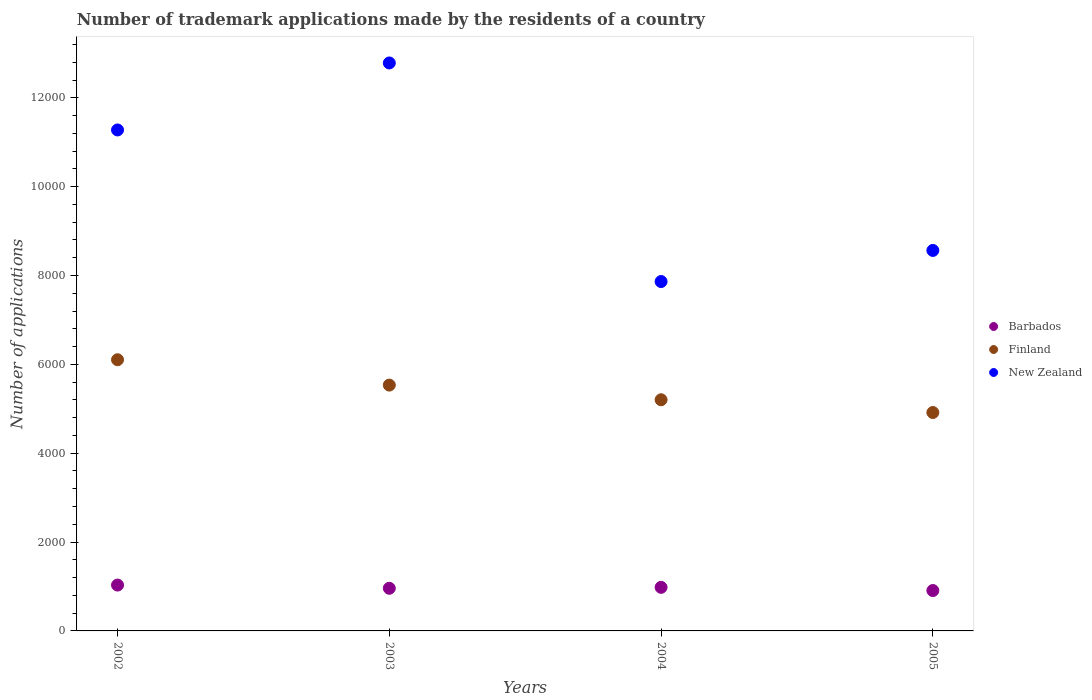How many different coloured dotlines are there?
Provide a succinct answer. 3. Is the number of dotlines equal to the number of legend labels?
Provide a short and direct response. Yes. What is the number of trademark applications made by the residents in Finland in 2002?
Provide a succinct answer. 6104. Across all years, what is the maximum number of trademark applications made by the residents in Finland?
Your response must be concise. 6104. Across all years, what is the minimum number of trademark applications made by the residents in New Zealand?
Your answer should be compact. 7864. In which year was the number of trademark applications made by the residents in New Zealand minimum?
Provide a succinct answer. 2004. What is the total number of trademark applications made by the residents in Finland in the graph?
Offer a very short reply. 2.18e+04. What is the difference between the number of trademark applications made by the residents in New Zealand in 2004 and that in 2005?
Make the answer very short. -700. What is the difference between the number of trademark applications made by the residents in New Zealand in 2004 and the number of trademark applications made by the residents in Finland in 2005?
Provide a succinct answer. 2948. What is the average number of trademark applications made by the residents in New Zealand per year?
Provide a short and direct response. 1.01e+04. In the year 2005, what is the difference between the number of trademark applications made by the residents in Finland and number of trademark applications made by the residents in Barbados?
Your response must be concise. 4007. In how many years, is the number of trademark applications made by the residents in New Zealand greater than 2000?
Your answer should be compact. 4. What is the ratio of the number of trademark applications made by the residents in Barbados in 2002 to that in 2003?
Your answer should be compact. 1.07. What is the difference between the highest and the second highest number of trademark applications made by the residents in Barbados?
Give a very brief answer. 51. What is the difference between the highest and the lowest number of trademark applications made by the residents in New Zealand?
Offer a terse response. 4920. Does the number of trademark applications made by the residents in Barbados monotonically increase over the years?
Keep it short and to the point. No. Is the number of trademark applications made by the residents in Finland strictly less than the number of trademark applications made by the residents in New Zealand over the years?
Provide a short and direct response. Yes. How many dotlines are there?
Provide a short and direct response. 3. What is the difference between two consecutive major ticks on the Y-axis?
Give a very brief answer. 2000. Does the graph contain any zero values?
Offer a terse response. No. Where does the legend appear in the graph?
Make the answer very short. Center right. How many legend labels are there?
Your response must be concise. 3. What is the title of the graph?
Provide a succinct answer. Number of trademark applications made by the residents of a country. What is the label or title of the Y-axis?
Give a very brief answer. Number of applications. What is the Number of applications of Barbados in 2002?
Your answer should be compact. 1032. What is the Number of applications in Finland in 2002?
Offer a terse response. 6104. What is the Number of applications of New Zealand in 2002?
Give a very brief answer. 1.13e+04. What is the Number of applications of Barbados in 2003?
Your answer should be compact. 960. What is the Number of applications in Finland in 2003?
Offer a very short reply. 5533. What is the Number of applications of New Zealand in 2003?
Offer a terse response. 1.28e+04. What is the Number of applications of Barbados in 2004?
Offer a very short reply. 981. What is the Number of applications in Finland in 2004?
Provide a succinct answer. 5203. What is the Number of applications in New Zealand in 2004?
Give a very brief answer. 7864. What is the Number of applications of Barbados in 2005?
Provide a succinct answer. 909. What is the Number of applications in Finland in 2005?
Provide a short and direct response. 4916. What is the Number of applications in New Zealand in 2005?
Give a very brief answer. 8564. Across all years, what is the maximum Number of applications in Barbados?
Provide a short and direct response. 1032. Across all years, what is the maximum Number of applications in Finland?
Provide a succinct answer. 6104. Across all years, what is the maximum Number of applications in New Zealand?
Make the answer very short. 1.28e+04. Across all years, what is the minimum Number of applications in Barbados?
Ensure brevity in your answer.  909. Across all years, what is the minimum Number of applications of Finland?
Your answer should be compact. 4916. Across all years, what is the minimum Number of applications in New Zealand?
Your answer should be compact. 7864. What is the total Number of applications in Barbados in the graph?
Your response must be concise. 3882. What is the total Number of applications in Finland in the graph?
Provide a succinct answer. 2.18e+04. What is the total Number of applications in New Zealand in the graph?
Keep it short and to the point. 4.05e+04. What is the difference between the Number of applications in Finland in 2002 and that in 2003?
Your answer should be very brief. 571. What is the difference between the Number of applications of New Zealand in 2002 and that in 2003?
Your response must be concise. -1508. What is the difference between the Number of applications of Finland in 2002 and that in 2004?
Ensure brevity in your answer.  901. What is the difference between the Number of applications of New Zealand in 2002 and that in 2004?
Provide a short and direct response. 3412. What is the difference between the Number of applications of Barbados in 2002 and that in 2005?
Offer a very short reply. 123. What is the difference between the Number of applications in Finland in 2002 and that in 2005?
Provide a succinct answer. 1188. What is the difference between the Number of applications in New Zealand in 2002 and that in 2005?
Offer a terse response. 2712. What is the difference between the Number of applications of Finland in 2003 and that in 2004?
Provide a short and direct response. 330. What is the difference between the Number of applications of New Zealand in 2003 and that in 2004?
Keep it short and to the point. 4920. What is the difference between the Number of applications in Finland in 2003 and that in 2005?
Your answer should be very brief. 617. What is the difference between the Number of applications in New Zealand in 2003 and that in 2005?
Offer a very short reply. 4220. What is the difference between the Number of applications in Barbados in 2004 and that in 2005?
Make the answer very short. 72. What is the difference between the Number of applications of Finland in 2004 and that in 2005?
Ensure brevity in your answer.  287. What is the difference between the Number of applications of New Zealand in 2004 and that in 2005?
Your answer should be compact. -700. What is the difference between the Number of applications in Barbados in 2002 and the Number of applications in Finland in 2003?
Offer a terse response. -4501. What is the difference between the Number of applications of Barbados in 2002 and the Number of applications of New Zealand in 2003?
Make the answer very short. -1.18e+04. What is the difference between the Number of applications of Finland in 2002 and the Number of applications of New Zealand in 2003?
Provide a succinct answer. -6680. What is the difference between the Number of applications of Barbados in 2002 and the Number of applications of Finland in 2004?
Your answer should be compact. -4171. What is the difference between the Number of applications of Barbados in 2002 and the Number of applications of New Zealand in 2004?
Give a very brief answer. -6832. What is the difference between the Number of applications of Finland in 2002 and the Number of applications of New Zealand in 2004?
Your response must be concise. -1760. What is the difference between the Number of applications of Barbados in 2002 and the Number of applications of Finland in 2005?
Your answer should be very brief. -3884. What is the difference between the Number of applications of Barbados in 2002 and the Number of applications of New Zealand in 2005?
Keep it short and to the point. -7532. What is the difference between the Number of applications in Finland in 2002 and the Number of applications in New Zealand in 2005?
Your answer should be compact. -2460. What is the difference between the Number of applications of Barbados in 2003 and the Number of applications of Finland in 2004?
Make the answer very short. -4243. What is the difference between the Number of applications of Barbados in 2003 and the Number of applications of New Zealand in 2004?
Your response must be concise. -6904. What is the difference between the Number of applications in Finland in 2003 and the Number of applications in New Zealand in 2004?
Your answer should be compact. -2331. What is the difference between the Number of applications in Barbados in 2003 and the Number of applications in Finland in 2005?
Your response must be concise. -3956. What is the difference between the Number of applications of Barbados in 2003 and the Number of applications of New Zealand in 2005?
Your answer should be very brief. -7604. What is the difference between the Number of applications in Finland in 2003 and the Number of applications in New Zealand in 2005?
Ensure brevity in your answer.  -3031. What is the difference between the Number of applications of Barbados in 2004 and the Number of applications of Finland in 2005?
Offer a very short reply. -3935. What is the difference between the Number of applications in Barbados in 2004 and the Number of applications in New Zealand in 2005?
Offer a terse response. -7583. What is the difference between the Number of applications in Finland in 2004 and the Number of applications in New Zealand in 2005?
Provide a short and direct response. -3361. What is the average Number of applications of Barbados per year?
Your response must be concise. 970.5. What is the average Number of applications in Finland per year?
Make the answer very short. 5439. What is the average Number of applications of New Zealand per year?
Provide a succinct answer. 1.01e+04. In the year 2002, what is the difference between the Number of applications of Barbados and Number of applications of Finland?
Offer a terse response. -5072. In the year 2002, what is the difference between the Number of applications of Barbados and Number of applications of New Zealand?
Keep it short and to the point. -1.02e+04. In the year 2002, what is the difference between the Number of applications of Finland and Number of applications of New Zealand?
Give a very brief answer. -5172. In the year 2003, what is the difference between the Number of applications of Barbados and Number of applications of Finland?
Make the answer very short. -4573. In the year 2003, what is the difference between the Number of applications in Barbados and Number of applications in New Zealand?
Provide a succinct answer. -1.18e+04. In the year 2003, what is the difference between the Number of applications in Finland and Number of applications in New Zealand?
Give a very brief answer. -7251. In the year 2004, what is the difference between the Number of applications in Barbados and Number of applications in Finland?
Provide a succinct answer. -4222. In the year 2004, what is the difference between the Number of applications in Barbados and Number of applications in New Zealand?
Your response must be concise. -6883. In the year 2004, what is the difference between the Number of applications of Finland and Number of applications of New Zealand?
Your response must be concise. -2661. In the year 2005, what is the difference between the Number of applications in Barbados and Number of applications in Finland?
Offer a terse response. -4007. In the year 2005, what is the difference between the Number of applications of Barbados and Number of applications of New Zealand?
Your answer should be compact. -7655. In the year 2005, what is the difference between the Number of applications in Finland and Number of applications in New Zealand?
Provide a short and direct response. -3648. What is the ratio of the Number of applications of Barbados in 2002 to that in 2003?
Offer a terse response. 1.07. What is the ratio of the Number of applications of Finland in 2002 to that in 2003?
Offer a terse response. 1.1. What is the ratio of the Number of applications of New Zealand in 2002 to that in 2003?
Give a very brief answer. 0.88. What is the ratio of the Number of applications of Barbados in 2002 to that in 2004?
Give a very brief answer. 1.05. What is the ratio of the Number of applications in Finland in 2002 to that in 2004?
Keep it short and to the point. 1.17. What is the ratio of the Number of applications in New Zealand in 2002 to that in 2004?
Ensure brevity in your answer.  1.43. What is the ratio of the Number of applications in Barbados in 2002 to that in 2005?
Offer a very short reply. 1.14. What is the ratio of the Number of applications of Finland in 2002 to that in 2005?
Offer a very short reply. 1.24. What is the ratio of the Number of applications of New Zealand in 2002 to that in 2005?
Keep it short and to the point. 1.32. What is the ratio of the Number of applications of Barbados in 2003 to that in 2004?
Offer a very short reply. 0.98. What is the ratio of the Number of applications in Finland in 2003 to that in 2004?
Your answer should be compact. 1.06. What is the ratio of the Number of applications of New Zealand in 2003 to that in 2004?
Make the answer very short. 1.63. What is the ratio of the Number of applications of Barbados in 2003 to that in 2005?
Give a very brief answer. 1.06. What is the ratio of the Number of applications of Finland in 2003 to that in 2005?
Your response must be concise. 1.13. What is the ratio of the Number of applications of New Zealand in 2003 to that in 2005?
Keep it short and to the point. 1.49. What is the ratio of the Number of applications of Barbados in 2004 to that in 2005?
Provide a succinct answer. 1.08. What is the ratio of the Number of applications in Finland in 2004 to that in 2005?
Offer a very short reply. 1.06. What is the ratio of the Number of applications in New Zealand in 2004 to that in 2005?
Provide a short and direct response. 0.92. What is the difference between the highest and the second highest Number of applications in Barbados?
Provide a short and direct response. 51. What is the difference between the highest and the second highest Number of applications of Finland?
Make the answer very short. 571. What is the difference between the highest and the second highest Number of applications of New Zealand?
Provide a succinct answer. 1508. What is the difference between the highest and the lowest Number of applications of Barbados?
Offer a very short reply. 123. What is the difference between the highest and the lowest Number of applications in Finland?
Keep it short and to the point. 1188. What is the difference between the highest and the lowest Number of applications of New Zealand?
Ensure brevity in your answer.  4920. 